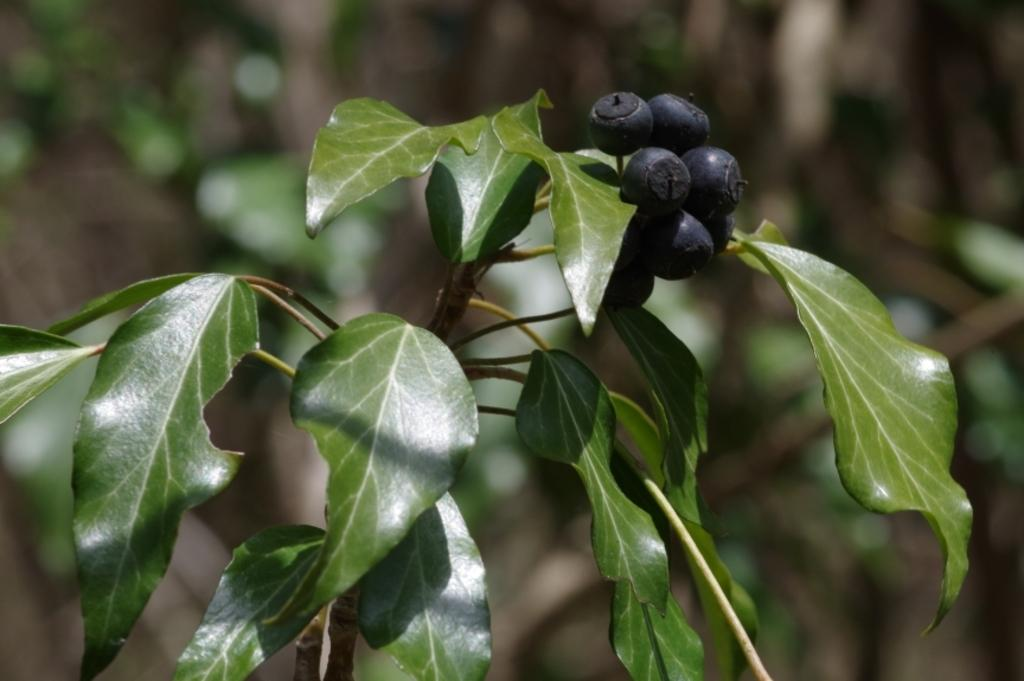What type of fruit can be seen in the image? There are berries in the image. What other plant parts are visible in the image? There are leaves and stems in the image. How would you describe the background of the image? The background of the image is blurred. What type of noise can be heard coming from the houses in the image? There are no houses present in the image, so it's not possible to determine what, if any, noise might be heard. Can you tell me how many apples are visible in the image? There are no apples present in the image; it features berries, leaves, and stems. 